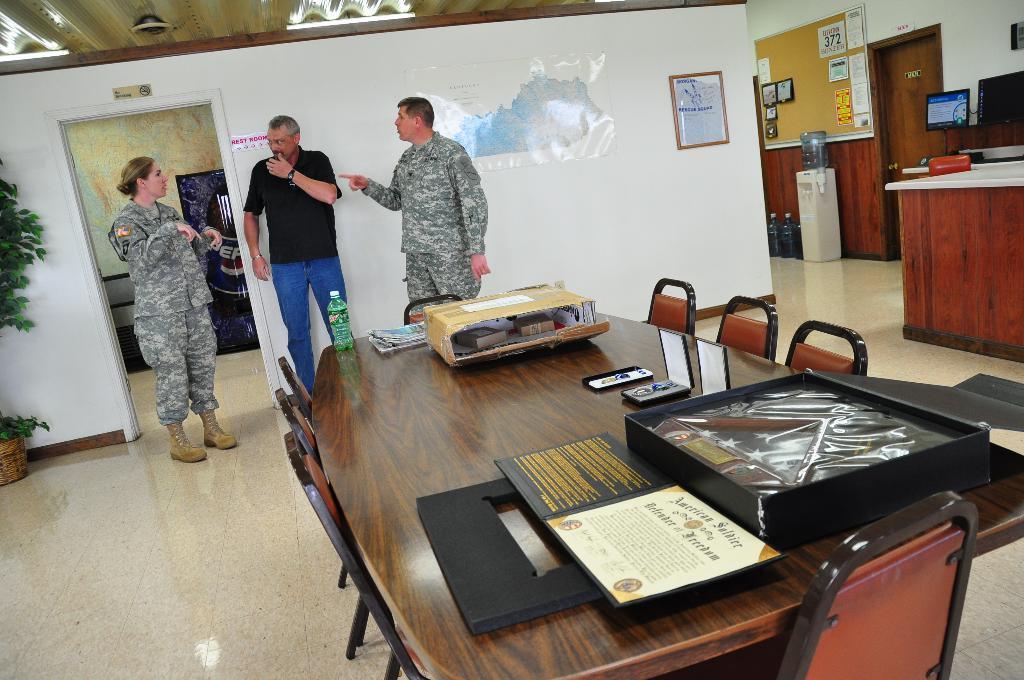In one or two sentences, can you explain what this image depicts? In this image I can see a table. On the table there is a cardboard box,bottle and the papers. In the back there are three people standing and there are some borders and frames attached to the wall. 